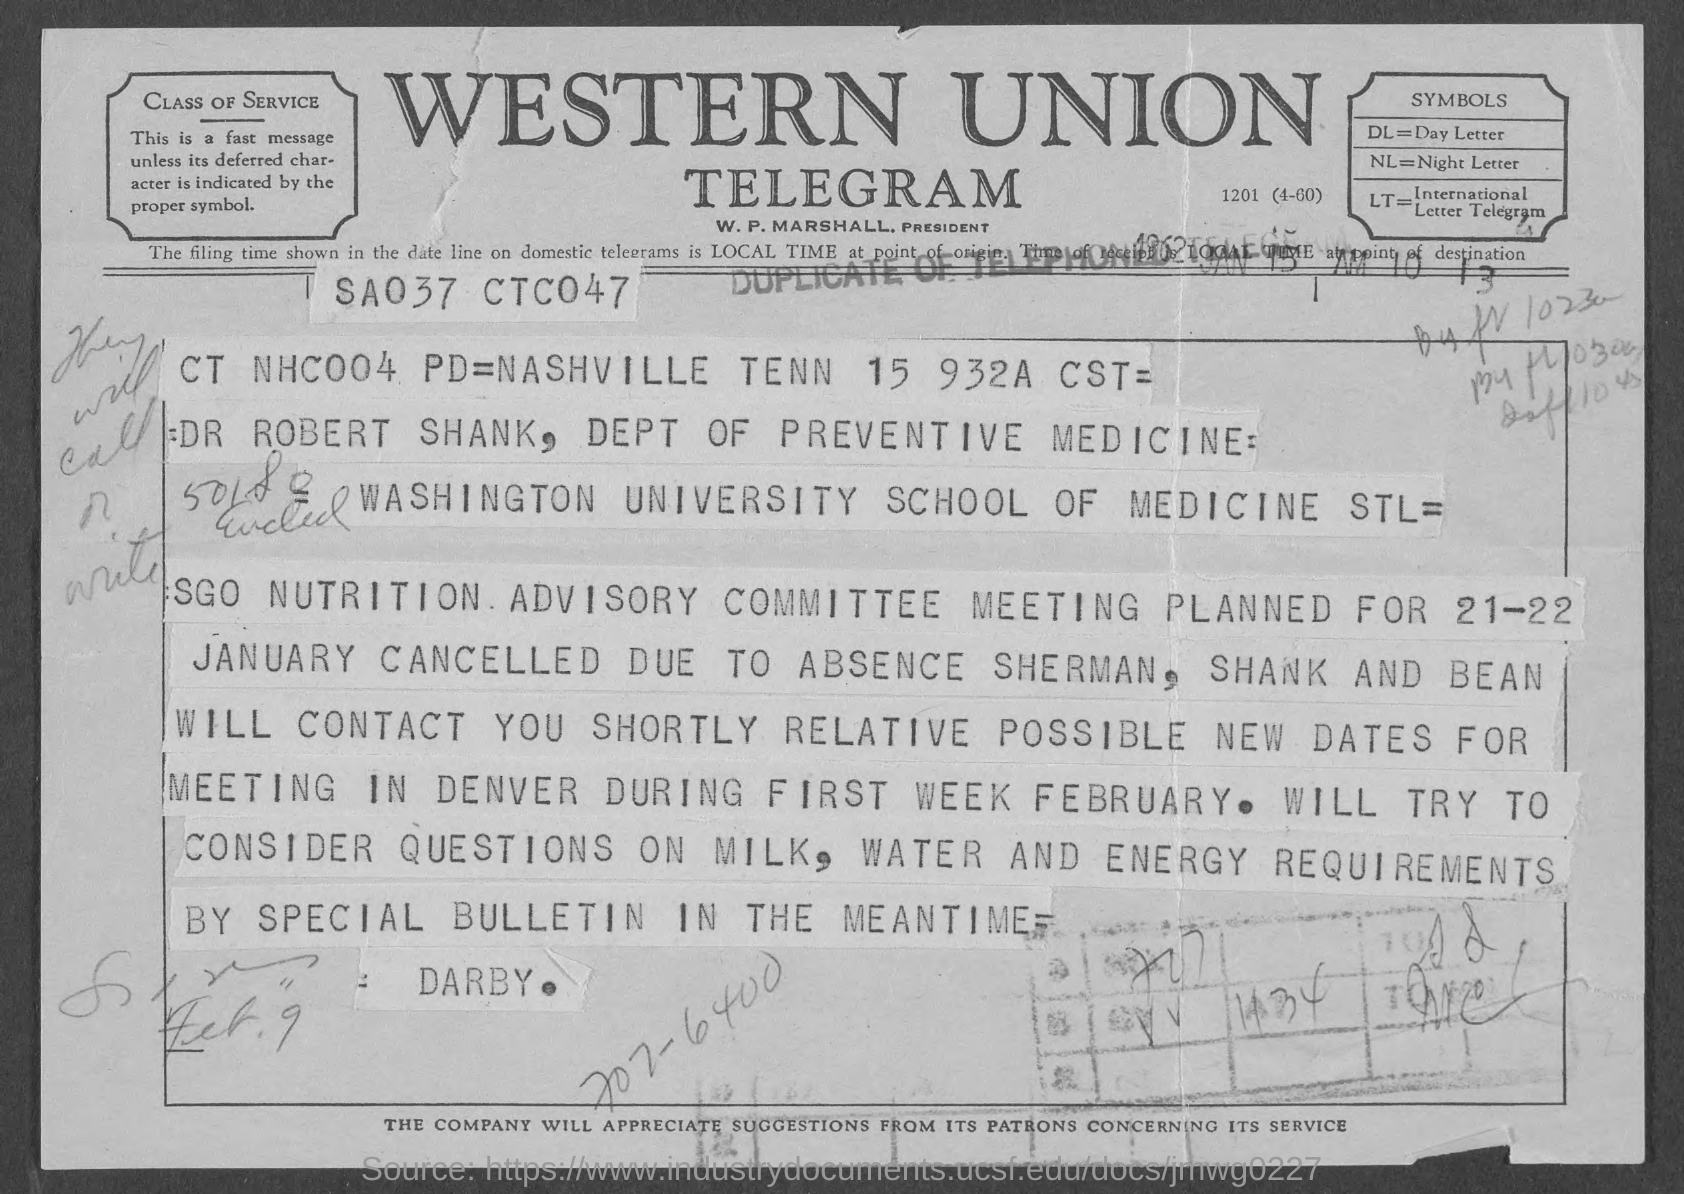Who is the president of western union telegram?
Keep it short and to the point. W. P. Marshall. What is the symbol for day letter ?
Your response must be concise. DL. What is the symbol for night letter?
Your answer should be compact. NL. What is the symbol for international letter telegram?
Your answer should be very brief. LT. 